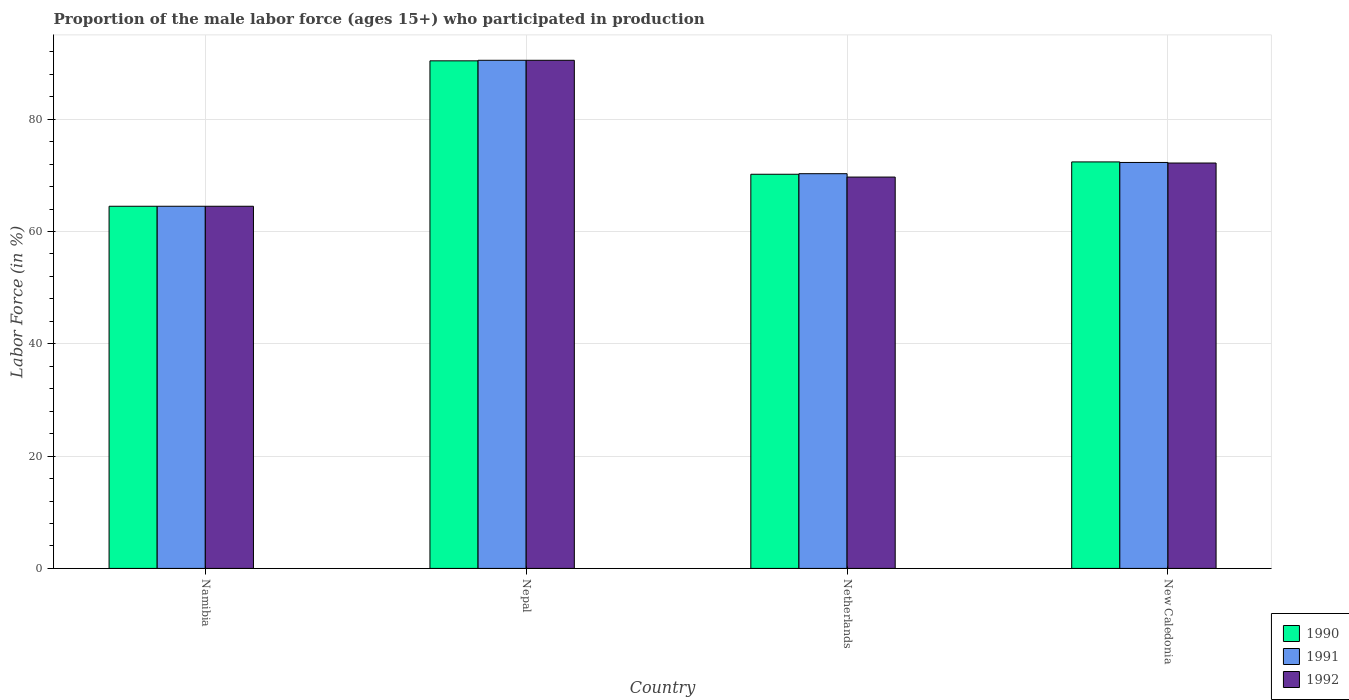How many bars are there on the 4th tick from the left?
Provide a succinct answer. 3. What is the label of the 1st group of bars from the left?
Offer a terse response. Namibia. In how many cases, is the number of bars for a given country not equal to the number of legend labels?
Provide a succinct answer. 0. What is the proportion of the male labor force who participated in production in 1991 in New Caledonia?
Ensure brevity in your answer.  72.3. Across all countries, what is the maximum proportion of the male labor force who participated in production in 1992?
Your answer should be compact. 90.5. Across all countries, what is the minimum proportion of the male labor force who participated in production in 1992?
Your response must be concise. 64.5. In which country was the proportion of the male labor force who participated in production in 1992 maximum?
Your answer should be compact. Nepal. In which country was the proportion of the male labor force who participated in production in 1990 minimum?
Give a very brief answer. Namibia. What is the total proportion of the male labor force who participated in production in 1992 in the graph?
Keep it short and to the point. 296.9. What is the difference between the proportion of the male labor force who participated in production in 1991 in Netherlands and the proportion of the male labor force who participated in production in 1992 in New Caledonia?
Give a very brief answer. -1.9. What is the average proportion of the male labor force who participated in production in 1990 per country?
Provide a succinct answer. 74.38. What is the difference between the proportion of the male labor force who participated in production of/in 1990 and proportion of the male labor force who participated in production of/in 1991 in Namibia?
Make the answer very short. 0. In how many countries, is the proportion of the male labor force who participated in production in 1990 greater than 32 %?
Your response must be concise. 4. What is the ratio of the proportion of the male labor force who participated in production in 1990 in Namibia to that in Netherlands?
Make the answer very short. 0.92. Is the difference between the proportion of the male labor force who participated in production in 1990 in Netherlands and New Caledonia greater than the difference between the proportion of the male labor force who participated in production in 1991 in Netherlands and New Caledonia?
Ensure brevity in your answer.  No. What does the 3rd bar from the left in Namibia represents?
Your answer should be very brief. 1992. What does the 2nd bar from the right in Namibia represents?
Provide a short and direct response. 1991. Is it the case that in every country, the sum of the proportion of the male labor force who participated in production in 1990 and proportion of the male labor force who participated in production in 1991 is greater than the proportion of the male labor force who participated in production in 1992?
Offer a terse response. Yes. How many countries are there in the graph?
Your answer should be compact. 4. Are the values on the major ticks of Y-axis written in scientific E-notation?
Give a very brief answer. No. What is the title of the graph?
Offer a terse response. Proportion of the male labor force (ages 15+) who participated in production. What is the label or title of the Y-axis?
Keep it short and to the point. Labor Force (in %). What is the Labor Force (in %) of 1990 in Namibia?
Ensure brevity in your answer.  64.5. What is the Labor Force (in %) of 1991 in Namibia?
Your answer should be compact. 64.5. What is the Labor Force (in %) of 1992 in Namibia?
Your response must be concise. 64.5. What is the Labor Force (in %) of 1990 in Nepal?
Provide a short and direct response. 90.4. What is the Labor Force (in %) in 1991 in Nepal?
Give a very brief answer. 90.5. What is the Labor Force (in %) of 1992 in Nepal?
Ensure brevity in your answer.  90.5. What is the Labor Force (in %) of 1990 in Netherlands?
Ensure brevity in your answer.  70.2. What is the Labor Force (in %) of 1991 in Netherlands?
Your answer should be very brief. 70.3. What is the Labor Force (in %) of 1992 in Netherlands?
Your response must be concise. 69.7. What is the Labor Force (in %) of 1990 in New Caledonia?
Your answer should be compact. 72.4. What is the Labor Force (in %) of 1991 in New Caledonia?
Offer a terse response. 72.3. What is the Labor Force (in %) in 1992 in New Caledonia?
Give a very brief answer. 72.2. Across all countries, what is the maximum Labor Force (in %) of 1990?
Offer a terse response. 90.4. Across all countries, what is the maximum Labor Force (in %) in 1991?
Your response must be concise. 90.5. Across all countries, what is the maximum Labor Force (in %) of 1992?
Ensure brevity in your answer.  90.5. Across all countries, what is the minimum Labor Force (in %) of 1990?
Offer a terse response. 64.5. Across all countries, what is the minimum Labor Force (in %) in 1991?
Provide a short and direct response. 64.5. Across all countries, what is the minimum Labor Force (in %) of 1992?
Offer a very short reply. 64.5. What is the total Labor Force (in %) in 1990 in the graph?
Provide a succinct answer. 297.5. What is the total Labor Force (in %) in 1991 in the graph?
Make the answer very short. 297.6. What is the total Labor Force (in %) in 1992 in the graph?
Ensure brevity in your answer.  296.9. What is the difference between the Labor Force (in %) in 1990 in Namibia and that in Nepal?
Make the answer very short. -25.9. What is the difference between the Labor Force (in %) in 1991 in Namibia and that in Nepal?
Offer a terse response. -26. What is the difference between the Labor Force (in %) of 1990 in Namibia and that in Netherlands?
Your answer should be compact. -5.7. What is the difference between the Labor Force (in %) in 1991 in Namibia and that in Netherlands?
Ensure brevity in your answer.  -5.8. What is the difference between the Labor Force (in %) in 1990 in Namibia and that in New Caledonia?
Ensure brevity in your answer.  -7.9. What is the difference between the Labor Force (in %) in 1991 in Namibia and that in New Caledonia?
Give a very brief answer. -7.8. What is the difference between the Labor Force (in %) in 1990 in Nepal and that in Netherlands?
Keep it short and to the point. 20.2. What is the difference between the Labor Force (in %) in 1991 in Nepal and that in Netherlands?
Ensure brevity in your answer.  20.2. What is the difference between the Labor Force (in %) of 1992 in Nepal and that in Netherlands?
Your answer should be compact. 20.8. What is the difference between the Labor Force (in %) of 1991 in Netherlands and that in New Caledonia?
Your answer should be very brief. -2. What is the difference between the Labor Force (in %) of 1992 in Netherlands and that in New Caledonia?
Keep it short and to the point. -2.5. What is the difference between the Labor Force (in %) in 1990 in Namibia and the Labor Force (in %) in 1991 in Nepal?
Offer a very short reply. -26. What is the difference between the Labor Force (in %) of 1991 in Namibia and the Labor Force (in %) of 1992 in Nepal?
Offer a very short reply. -26. What is the difference between the Labor Force (in %) of 1990 in Namibia and the Labor Force (in %) of 1991 in Netherlands?
Your answer should be very brief. -5.8. What is the difference between the Labor Force (in %) in 1991 in Namibia and the Labor Force (in %) in 1992 in Netherlands?
Ensure brevity in your answer.  -5.2. What is the difference between the Labor Force (in %) of 1990 in Namibia and the Labor Force (in %) of 1991 in New Caledonia?
Your answer should be very brief. -7.8. What is the difference between the Labor Force (in %) of 1990 in Namibia and the Labor Force (in %) of 1992 in New Caledonia?
Your answer should be compact. -7.7. What is the difference between the Labor Force (in %) in 1990 in Nepal and the Labor Force (in %) in 1991 in Netherlands?
Offer a very short reply. 20.1. What is the difference between the Labor Force (in %) of 1990 in Nepal and the Labor Force (in %) of 1992 in Netherlands?
Ensure brevity in your answer.  20.7. What is the difference between the Labor Force (in %) of 1991 in Nepal and the Labor Force (in %) of 1992 in Netherlands?
Your answer should be very brief. 20.8. What is the difference between the Labor Force (in %) in 1990 in Nepal and the Labor Force (in %) in 1991 in New Caledonia?
Make the answer very short. 18.1. What is the difference between the Labor Force (in %) in 1991 in Nepal and the Labor Force (in %) in 1992 in New Caledonia?
Offer a terse response. 18.3. What is the difference between the Labor Force (in %) in 1990 in Netherlands and the Labor Force (in %) in 1991 in New Caledonia?
Offer a very short reply. -2.1. What is the difference between the Labor Force (in %) in 1991 in Netherlands and the Labor Force (in %) in 1992 in New Caledonia?
Ensure brevity in your answer.  -1.9. What is the average Labor Force (in %) in 1990 per country?
Give a very brief answer. 74.38. What is the average Labor Force (in %) in 1991 per country?
Keep it short and to the point. 74.4. What is the average Labor Force (in %) of 1992 per country?
Your response must be concise. 74.22. What is the difference between the Labor Force (in %) in 1991 and Labor Force (in %) in 1992 in Nepal?
Provide a succinct answer. 0. What is the difference between the Labor Force (in %) of 1990 and Labor Force (in %) of 1991 in Netherlands?
Provide a short and direct response. -0.1. What is the difference between the Labor Force (in %) in 1990 and Labor Force (in %) in 1992 in Netherlands?
Give a very brief answer. 0.5. What is the difference between the Labor Force (in %) of 1990 and Labor Force (in %) of 1991 in New Caledonia?
Your answer should be compact. 0.1. What is the difference between the Labor Force (in %) in 1991 and Labor Force (in %) in 1992 in New Caledonia?
Offer a terse response. 0.1. What is the ratio of the Labor Force (in %) of 1990 in Namibia to that in Nepal?
Your answer should be compact. 0.71. What is the ratio of the Labor Force (in %) of 1991 in Namibia to that in Nepal?
Your answer should be compact. 0.71. What is the ratio of the Labor Force (in %) in 1992 in Namibia to that in Nepal?
Give a very brief answer. 0.71. What is the ratio of the Labor Force (in %) in 1990 in Namibia to that in Netherlands?
Your answer should be very brief. 0.92. What is the ratio of the Labor Force (in %) of 1991 in Namibia to that in Netherlands?
Make the answer very short. 0.92. What is the ratio of the Labor Force (in %) of 1992 in Namibia to that in Netherlands?
Your answer should be very brief. 0.93. What is the ratio of the Labor Force (in %) in 1990 in Namibia to that in New Caledonia?
Make the answer very short. 0.89. What is the ratio of the Labor Force (in %) of 1991 in Namibia to that in New Caledonia?
Offer a terse response. 0.89. What is the ratio of the Labor Force (in %) of 1992 in Namibia to that in New Caledonia?
Your answer should be compact. 0.89. What is the ratio of the Labor Force (in %) in 1990 in Nepal to that in Netherlands?
Your answer should be compact. 1.29. What is the ratio of the Labor Force (in %) of 1991 in Nepal to that in Netherlands?
Provide a succinct answer. 1.29. What is the ratio of the Labor Force (in %) of 1992 in Nepal to that in Netherlands?
Your response must be concise. 1.3. What is the ratio of the Labor Force (in %) in 1990 in Nepal to that in New Caledonia?
Offer a very short reply. 1.25. What is the ratio of the Labor Force (in %) of 1991 in Nepal to that in New Caledonia?
Offer a terse response. 1.25. What is the ratio of the Labor Force (in %) of 1992 in Nepal to that in New Caledonia?
Your answer should be compact. 1.25. What is the ratio of the Labor Force (in %) of 1990 in Netherlands to that in New Caledonia?
Provide a short and direct response. 0.97. What is the ratio of the Labor Force (in %) of 1991 in Netherlands to that in New Caledonia?
Provide a short and direct response. 0.97. What is the ratio of the Labor Force (in %) of 1992 in Netherlands to that in New Caledonia?
Make the answer very short. 0.97. What is the difference between the highest and the lowest Labor Force (in %) in 1990?
Your response must be concise. 25.9. 